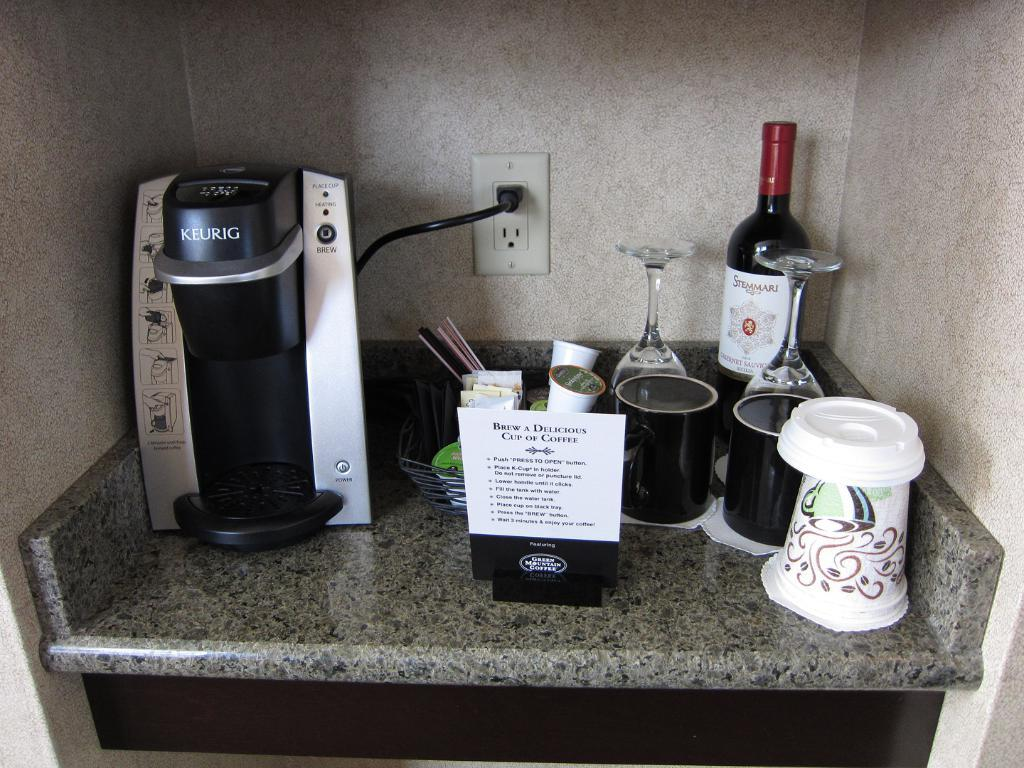Provide a one-sentence caption for the provided image. A Keurig sits on a counter with a sign that tells you how to brew a perfect cup of coffee, cups, wine glasses, and a bottle of Stemmari Cabernet Sauvignon. 